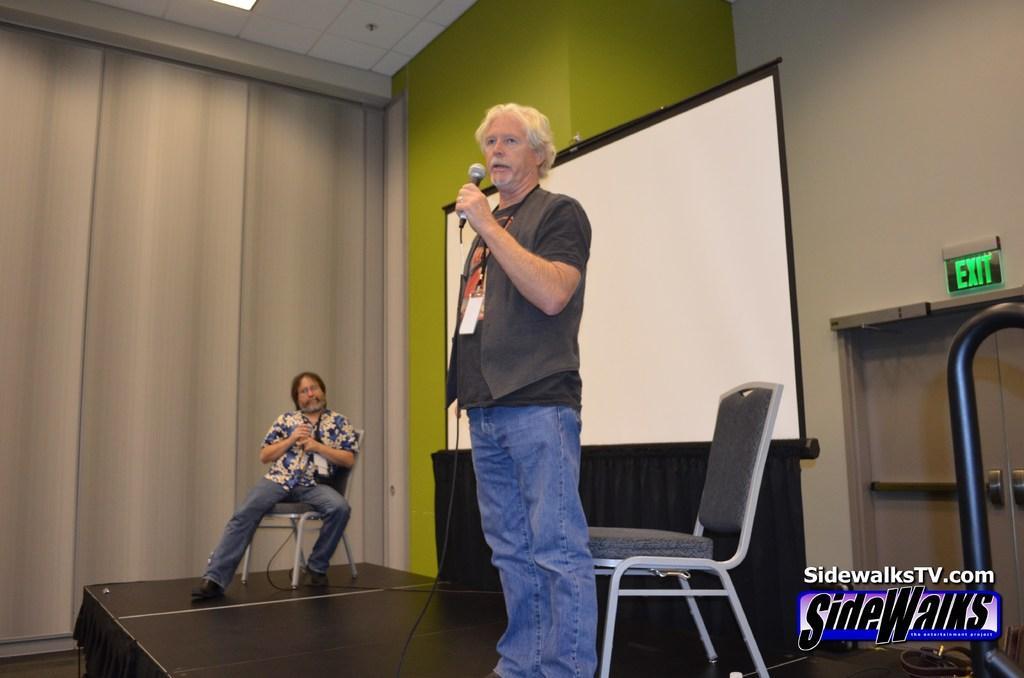Describe this image in one or two sentences. This is an inside view. Here I can see a man standing on the stage facing towards the left side, holding a mike in the hand and speaking. At the back of him there is a chair. In the background there is another man sitting on a chair and holding an object in the hands. At the back of these people there is a screen. On the right side there is a table and a metal rod. On the left side I can see the curtain. In the background there is a wall. In the bottom right there is some edited text. 